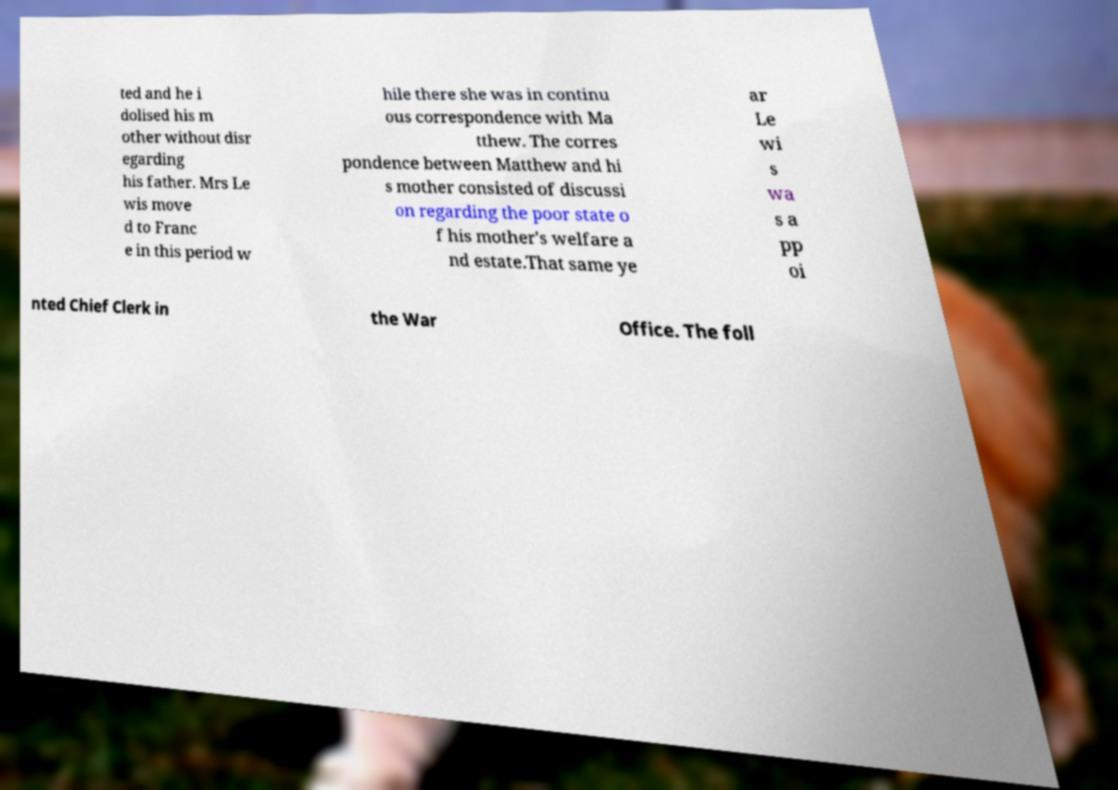What messages or text are displayed in this image? I need them in a readable, typed format. ted and he i dolised his m other without disr egarding his father. Mrs Le wis move d to Franc e in this period w hile there she was in continu ous correspondence with Ma tthew. The corres pondence between Matthew and hi s mother consisted of discussi on regarding the poor state o f his mother's welfare a nd estate.That same ye ar Le wi s wa s a pp oi nted Chief Clerk in the War Office. The foll 